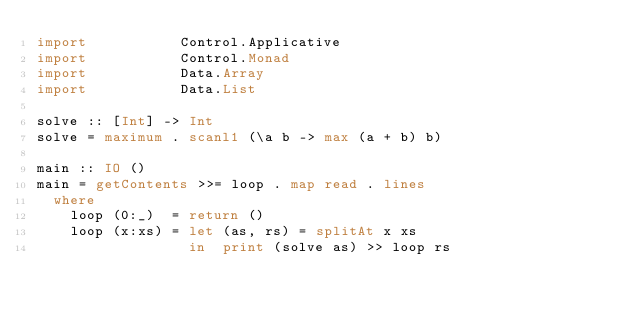Convert code to text. <code><loc_0><loc_0><loc_500><loc_500><_Haskell_>import           Control.Applicative
import           Control.Monad
import           Data.Array
import           Data.List

solve :: [Int] -> Int
solve = maximum . scanl1 (\a b -> max (a + b) b)

main :: IO ()
main = getContents >>= loop . map read . lines
  where
    loop (0:_)  = return ()
    loop (x:xs) = let (as, rs) = splitAt x xs
                  in  print (solve as) >> loop rs</code> 